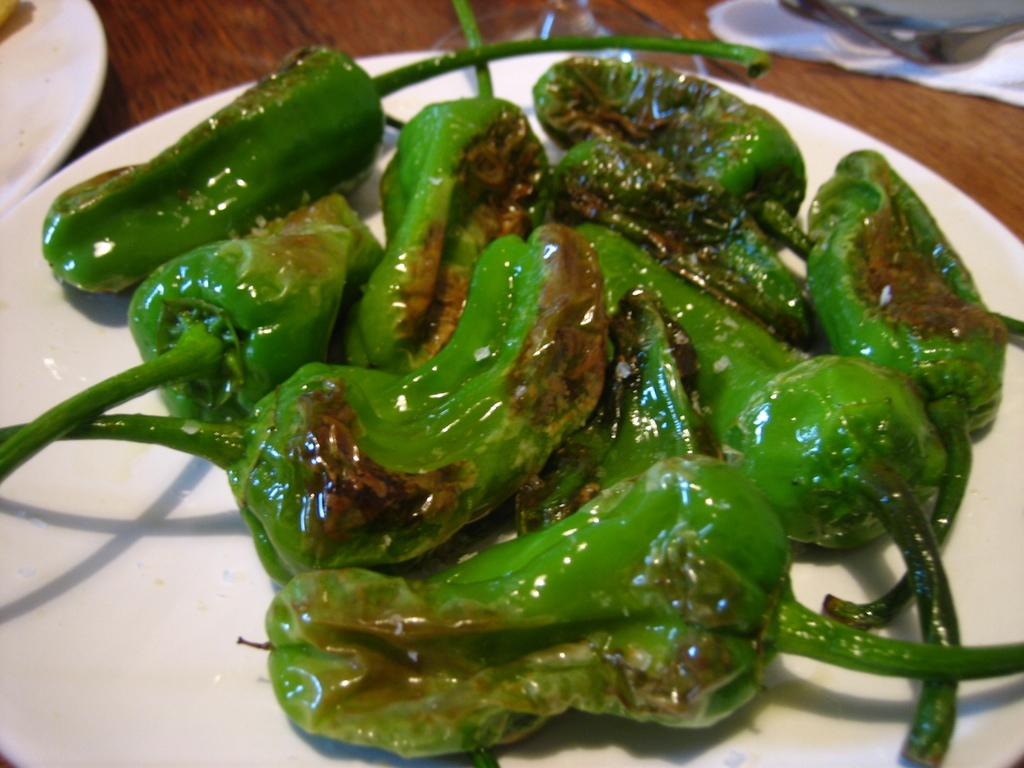What is on the plate that is visible in the image? There is a plate with food items in the image. Can you describe the white object in the top left corner of the image? There is a white object in the top left corner of the image, but its specific details are not clear from the provided facts. What objects are in the top right corner of the image? There are objects in the top right corner of the image, but their specific details are not clear from the provided facts. How does the zephyr affect the food on the plate in the image? There is no mention of a zephyr or any wind-related phenomenon in the image, so it cannot be determined how it might affect the food on the plate. 